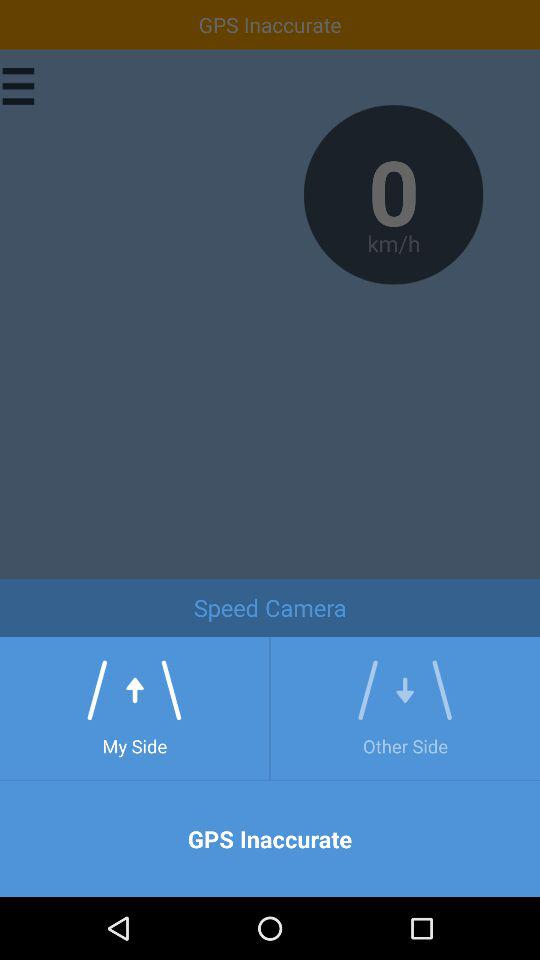How many km/h is the speed camera?
Answer the question using a single word or phrase. 0 